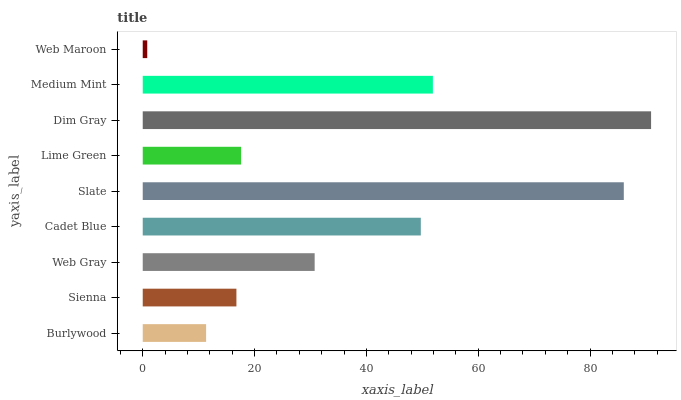Is Web Maroon the minimum?
Answer yes or no. Yes. Is Dim Gray the maximum?
Answer yes or no. Yes. Is Sienna the minimum?
Answer yes or no. No. Is Sienna the maximum?
Answer yes or no. No. Is Sienna greater than Burlywood?
Answer yes or no. Yes. Is Burlywood less than Sienna?
Answer yes or no. Yes. Is Burlywood greater than Sienna?
Answer yes or no. No. Is Sienna less than Burlywood?
Answer yes or no. No. Is Web Gray the high median?
Answer yes or no. Yes. Is Web Gray the low median?
Answer yes or no. Yes. Is Web Maroon the high median?
Answer yes or no. No. Is Web Maroon the low median?
Answer yes or no. No. 